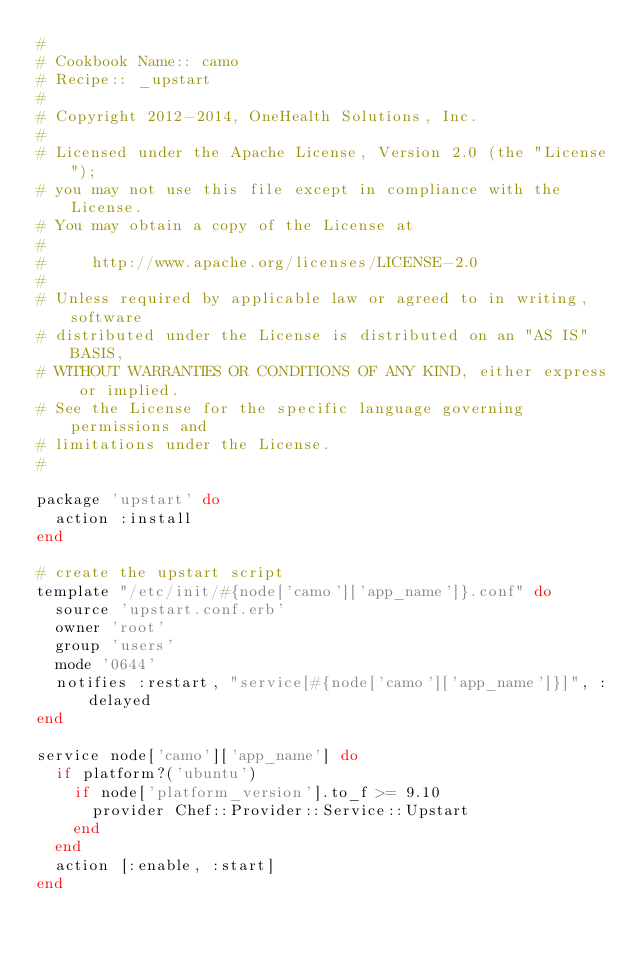<code> <loc_0><loc_0><loc_500><loc_500><_Ruby_>#
# Cookbook Name:: camo
# Recipe:: _upstart
#
# Copyright 2012-2014, OneHealth Solutions, Inc.
#
# Licensed under the Apache License, Version 2.0 (the "License");
# you may not use this file except in compliance with the License.
# You may obtain a copy of the License at
#
#     http://www.apache.org/licenses/LICENSE-2.0
#
# Unless required by applicable law or agreed to in writing, software
# distributed under the License is distributed on an "AS IS" BASIS,
# WITHOUT WARRANTIES OR CONDITIONS OF ANY KIND, either express or implied.
# See the License for the specific language governing permissions and
# limitations under the License.
#

package 'upstart' do
  action :install
end

# create the upstart script
template "/etc/init/#{node['camo']['app_name']}.conf" do
  source 'upstart.conf.erb'
  owner 'root'
  group 'users'
  mode '0644'
  notifies :restart, "service[#{node['camo']['app_name']}]", :delayed
end

service node['camo']['app_name'] do
  if platform?('ubuntu')
    if node['platform_version'].to_f >= 9.10
      provider Chef::Provider::Service::Upstart
    end
  end
  action [:enable, :start]
end
</code> 